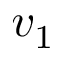<formula> <loc_0><loc_0><loc_500><loc_500>v _ { 1 }</formula> 